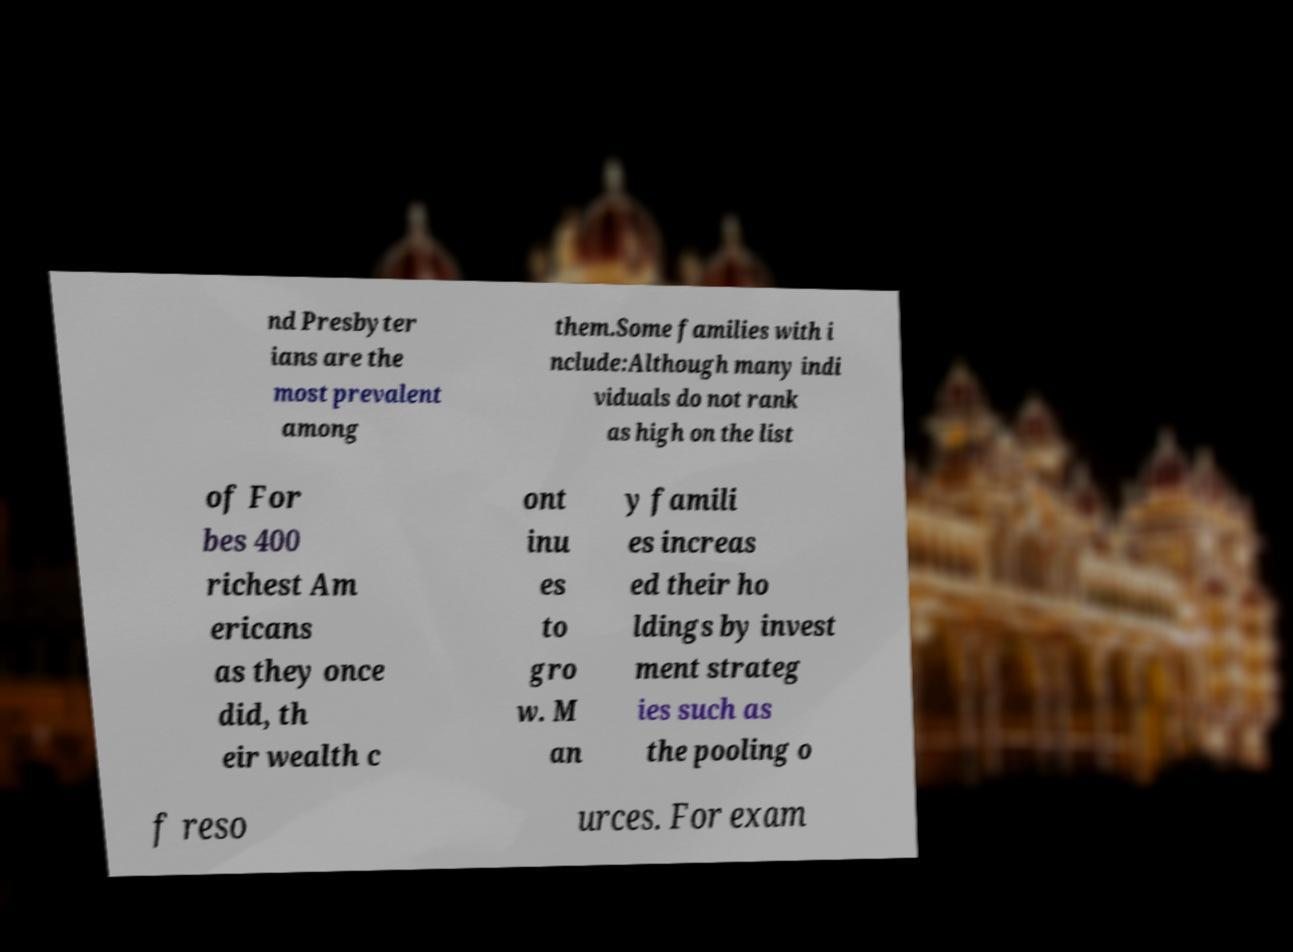Could you extract and type out the text from this image? nd Presbyter ians are the most prevalent among them.Some families with i nclude:Although many indi viduals do not rank as high on the list of For bes 400 richest Am ericans as they once did, th eir wealth c ont inu es to gro w. M an y famili es increas ed their ho ldings by invest ment strateg ies such as the pooling o f reso urces. For exam 